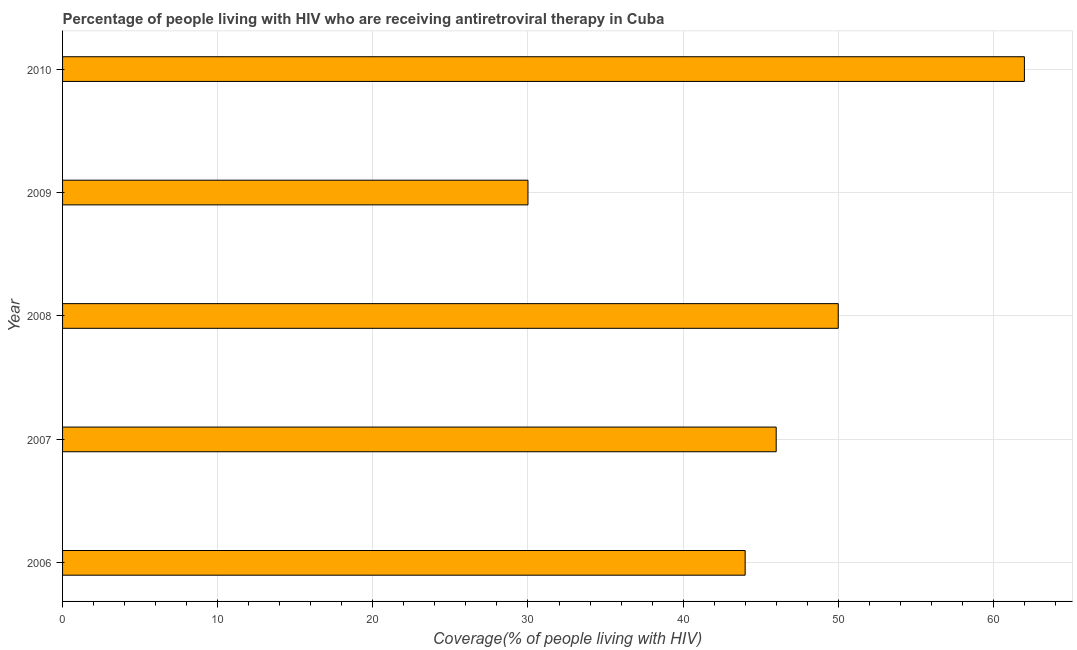Does the graph contain any zero values?
Keep it short and to the point. No. What is the title of the graph?
Give a very brief answer. Percentage of people living with HIV who are receiving antiretroviral therapy in Cuba. What is the label or title of the X-axis?
Ensure brevity in your answer.  Coverage(% of people living with HIV). Across all years, what is the minimum antiretroviral therapy coverage?
Make the answer very short. 30. In which year was the antiretroviral therapy coverage maximum?
Provide a succinct answer. 2010. In which year was the antiretroviral therapy coverage minimum?
Keep it short and to the point. 2009. What is the sum of the antiretroviral therapy coverage?
Ensure brevity in your answer.  232. What is the difference between the antiretroviral therapy coverage in 2008 and 2010?
Your answer should be very brief. -12. In how many years, is the antiretroviral therapy coverage greater than 46 %?
Provide a short and direct response. 2. What is the ratio of the antiretroviral therapy coverage in 2008 to that in 2010?
Your response must be concise. 0.81. Is the antiretroviral therapy coverage in 2007 less than that in 2009?
Offer a very short reply. No. Is the difference between the antiretroviral therapy coverage in 2006 and 2007 greater than the difference between any two years?
Provide a succinct answer. No. How many bars are there?
Keep it short and to the point. 5. What is the difference between the Coverage(% of people living with HIV) in 2006 and 2008?
Provide a succinct answer. -6. What is the difference between the Coverage(% of people living with HIV) in 2006 and 2010?
Provide a succinct answer. -18. What is the difference between the Coverage(% of people living with HIV) in 2007 and 2009?
Give a very brief answer. 16. What is the difference between the Coverage(% of people living with HIV) in 2008 and 2009?
Offer a terse response. 20. What is the difference between the Coverage(% of people living with HIV) in 2009 and 2010?
Offer a very short reply. -32. What is the ratio of the Coverage(% of people living with HIV) in 2006 to that in 2007?
Provide a succinct answer. 0.96. What is the ratio of the Coverage(% of people living with HIV) in 2006 to that in 2009?
Give a very brief answer. 1.47. What is the ratio of the Coverage(% of people living with HIV) in 2006 to that in 2010?
Offer a very short reply. 0.71. What is the ratio of the Coverage(% of people living with HIV) in 2007 to that in 2009?
Give a very brief answer. 1.53. What is the ratio of the Coverage(% of people living with HIV) in 2007 to that in 2010?
Your answer should be compact. 0.74. What is the ratio of the Coverage(% of people living with HIV) in 2008 to that in 2009?
Offer a terse response. 1.67. What is the ratio of the Coverage(% of people living with HIV) in 2008 to that in 2010?
Offer a terse response. 0.81. What is the ratio of the Coverage(% of people living with HIV) in 2009 to that in 2010?
Provide a succinct answer. 0.48. 